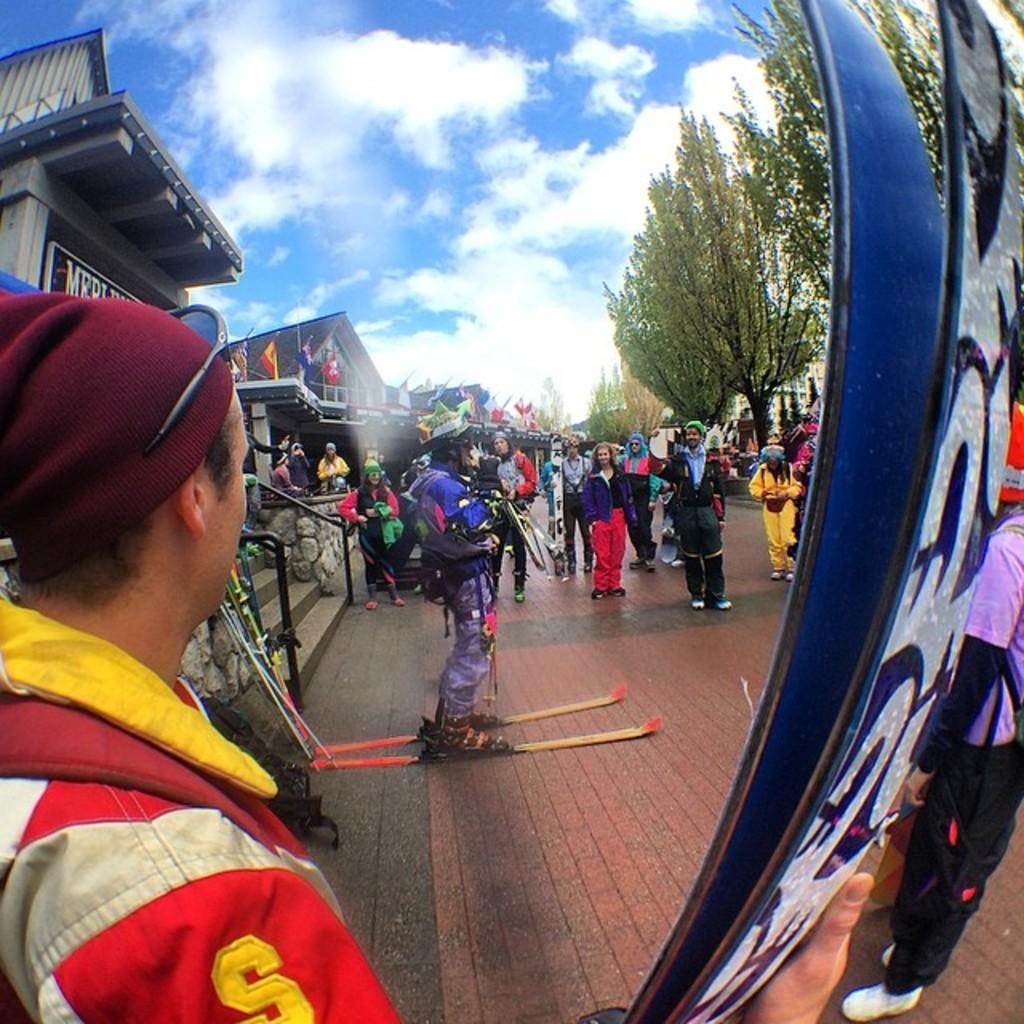<image>
Summarize the visual content of the image. A person wearing a red outfit with the letter s with other skiers. 